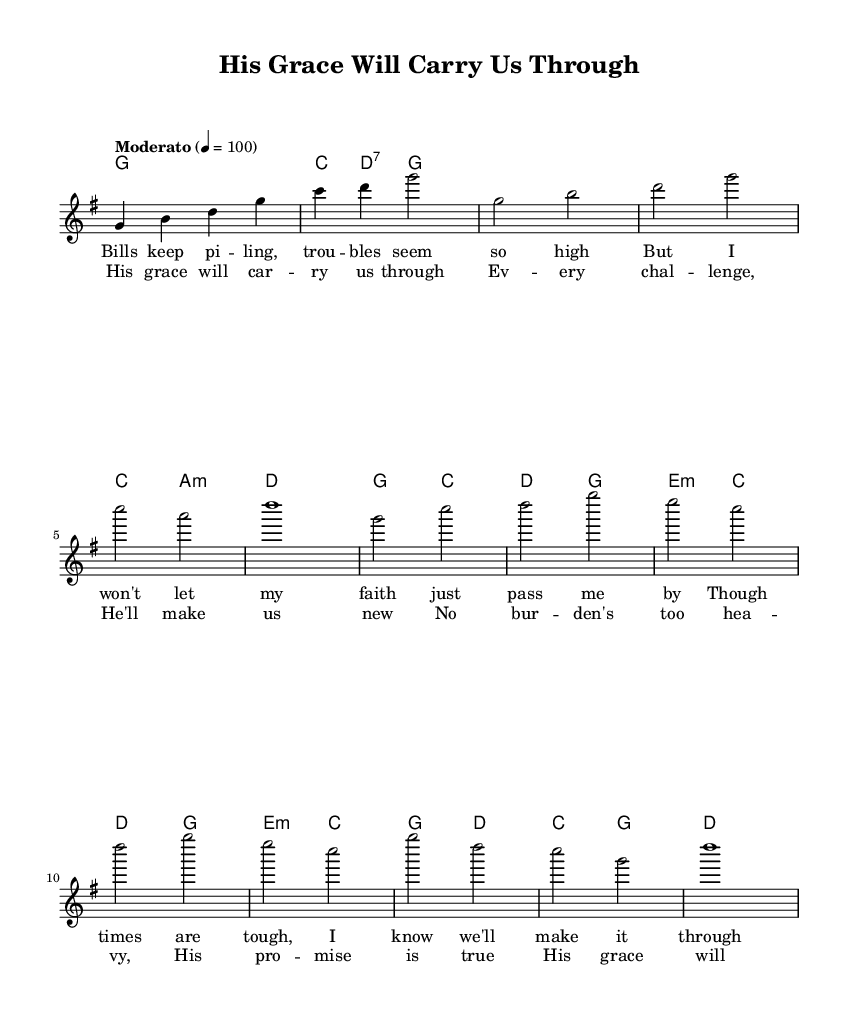What is the key signature of this music? The key signature is G major, which has one sharp (F#). This is indicated at the beginning of the staff before the first note.
Answer: G major What is the time signature of this music? The time signature is 4/4, meaning there are four beats in each measure and a quarter note gets one beat. This is shown at the beginning of the score next to the key signature.
Answer: 4/4 What is the tempo marking for this piece? The tempo marking is "Moderato," which indicates a moderate speed for the piece. This is found near the top of the score, specifying how fast the music should be played.
Answer: Moderato In which measure does the chorus begin? The chorus begins in measure 5, where the notation shifts to the chorus lyrics. Counting starts from the intro, which occupies the first four measures.
Answer: 5 What are the main themes expressed in the lyrics? The main themes reflect hope and faith in overcoming financial struggles through divine support. This is evident in the lyrics discussing burdens and God's grace.
Answer: Hope and faith What chord follows the first verse in measure 4? The chord following the first verse in measure 4 is a D major chord, which is indicated in the harmonies part right above the lyrics.
Answer: D major How many verses are presented in this piece? There is one verse presented, as shown in the structure of the music. The lyrics indicate the first verse followed by the chorus, with no subsequent verses listed.
Answer: One verse 